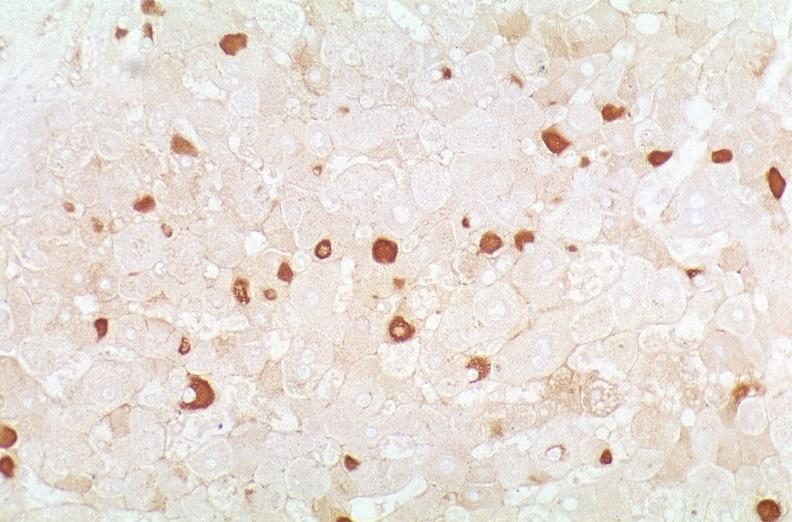does this image show hepatitis b virus, hepatocellular carcinoma?
Answer the question using a single word or phrase. Yes 